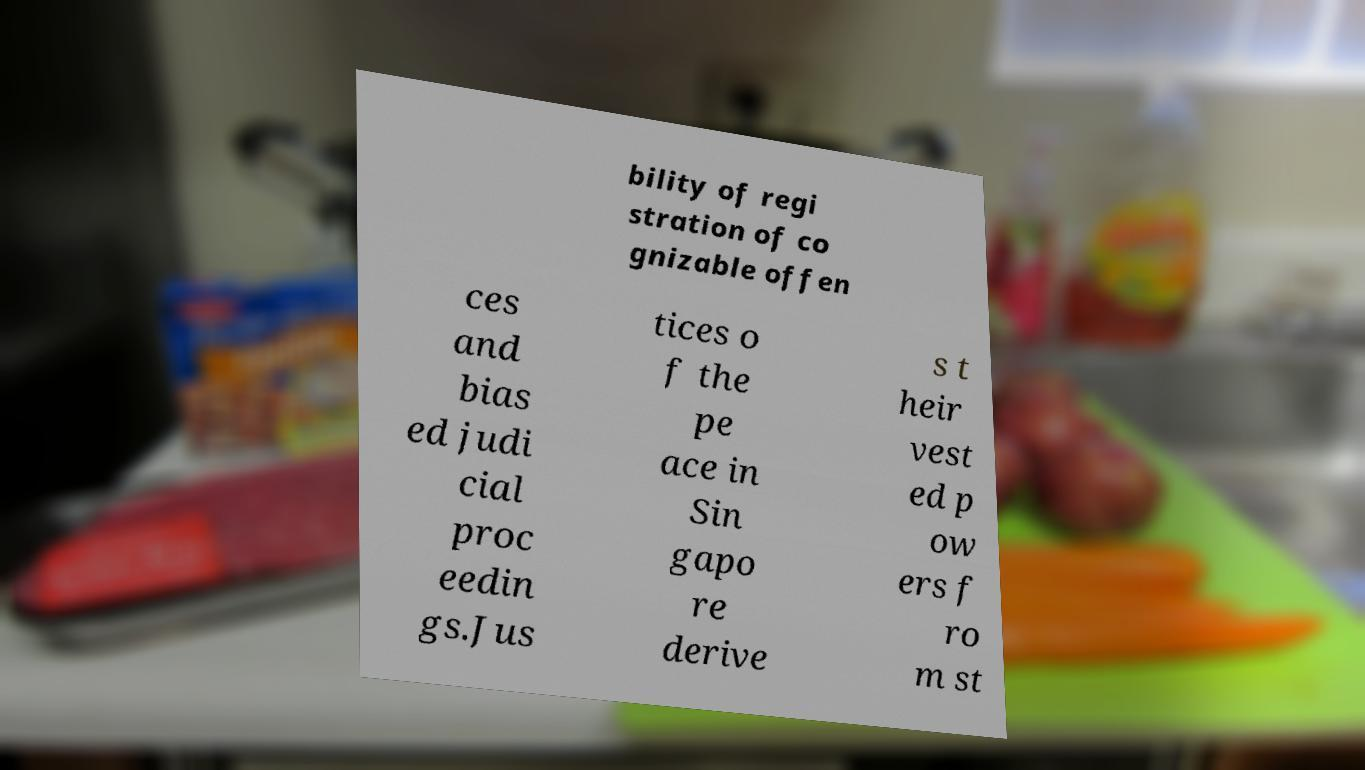I need the written content from this picture converted into text. Can you do that? bility of regi stration of co gnizable offen ces and bias ed judi cial proc eedin gs.Jus tices o f the pe ace in Sin gapo re derive s t heir vest ed p ow ers f ro m st 